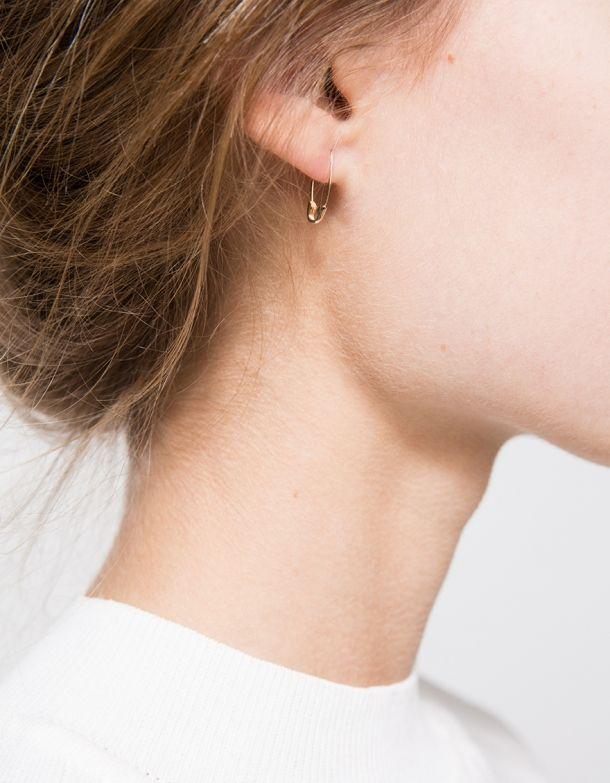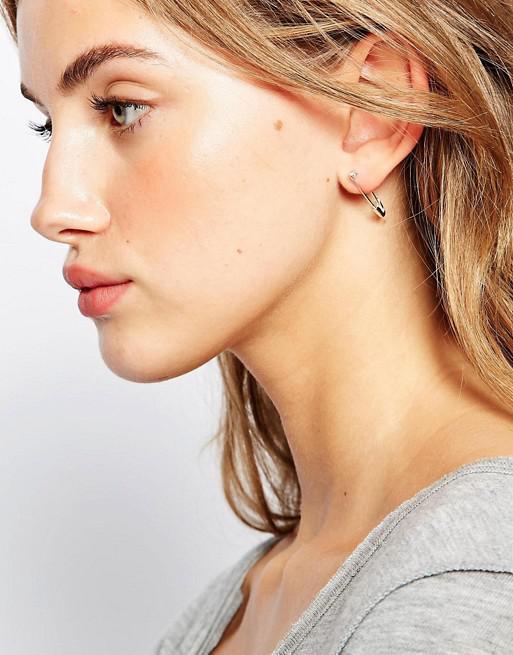The first image is the image on the left, the second image is the image on the right. Considering the images on both sides, is "There are two women who are both wearing earrings." valid? Answer yes or no. Yes. The first image is the image on the left, the second image is the image on the right. Evaluate the accuracy of this statement regarding the images: "One of the images shows a safety pin that is in a location other than a woman's ear.". Is it true? Answer yes or no. No. 